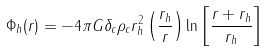Convert formula to latex. <formula><loc_0><loc_0><loc_500><loc_500>\Phi _ { h } ( r ) = - 4 \pi G \delta _ { c } \rho _ { c } r _ { h } ^ { 2 } \left ( \frac { r _ { h } } { r } \right ) \ln \left [ \frac { r + r _ { h } } { r _ { h } } \right ]</formula> 